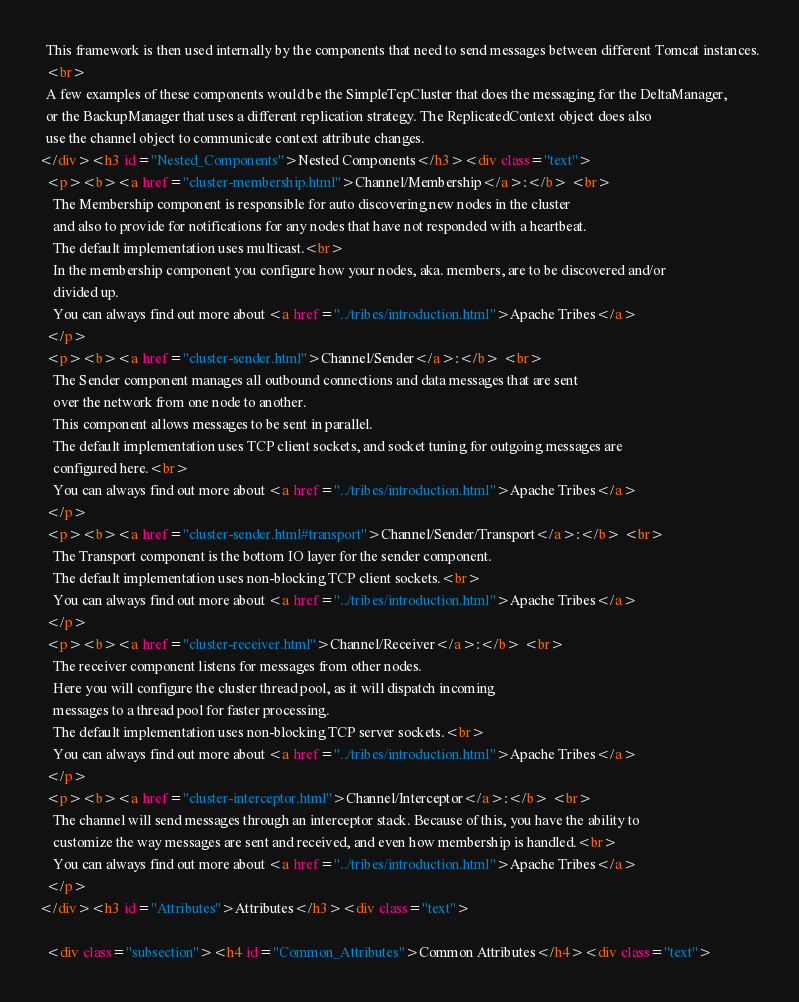Convert code to text. <code><loc_0><loc_0><loc_500><loc_500><_HTML_>  This framework is then used internally by the components that need to send messages between different Tomcat instances.
  <br>
  A few examples of these components would be the SimpleTcpCluster that does the messaging for the DeltaManager,
  or the BackupManager that uses a different replication strategy. The ReplicatedContext object does also
  use the channel object to communicate context attribute changes.
</div><h3 id="Nested_Components">Nested Components</h3><div class="text">
  <p><b><a href="cluster-membership.html">Channel/Membership</a>:</b> <br>
    The Membership component is responsible for auto discovering new nodes in the cluster
    and also to provide for notifications for any nodes that have not responded with a heartbeat.
    The default implementation uses multicast.<br>
    In the membership component you configure how your nodes, aka. members, are to be discovered and/or
    divided up.
    You can always find out more about <a href="../tribes/introduction.html">Apache Tribes</a>
  </p>
  <p><b><a href="cluster-sender.html">Channel/Sender</a>:</b> <br>
    The Sender component manages all outbound connections and data messages that are sent
    over the network from one node to another.
    This component allows messages to be sent in parallel.
    The default implementation uses TCP client sockets, and socket tuning for outgoing messages are
    configured here.<br>
    You can always find out more about <a href="../tribes/introduction.html">Apache Tribes</a>
  </p>
  <p><b><a href="cluster-sender.html#transport">Channel/Sender/Transport</a>:</b> <br>
    The Transport component is the bottom IO layer for the sender component.
    The default implementation uses non-blocking TCP client sockets.<br>
    You can always find out more about <a href="../tribes/introduction.html">Apache Tribes</a>
  </p>
  <p><b><a href="cluster-receiver.html">Channel/Receiver</a>:</b> <br>
    The receiver component listens for messages from other nodes.
    Here you will configure the cluster thread pool, as it will dispatch incoming
    messages to a thread pool for faster processing.
    The default implementation uses non-blocking TCP server sockets.<br>
    You can always find out more about <a href="../tribes/introduction.html">Apache Tribes</a>
  </p>
  <p><b><a href="cluster-interceptor.html">Channel/Interceptor</a>:</b> <br>
    The channel will send messages through an interceptor stack. Because of this, you have the ability to
    customize the way messages are sent and received, and even how membership is handled.<br>
    You can always find out more about <a href="../tribes/introduction.html">Apache Tribes</a>
  </p>
</div><h3 id="Attributes">Attributes</h3><div class="text">

  <div class="subsection"><h4 id="Common_Attributes">Common Attributes</h4><div class="text">
</code> 